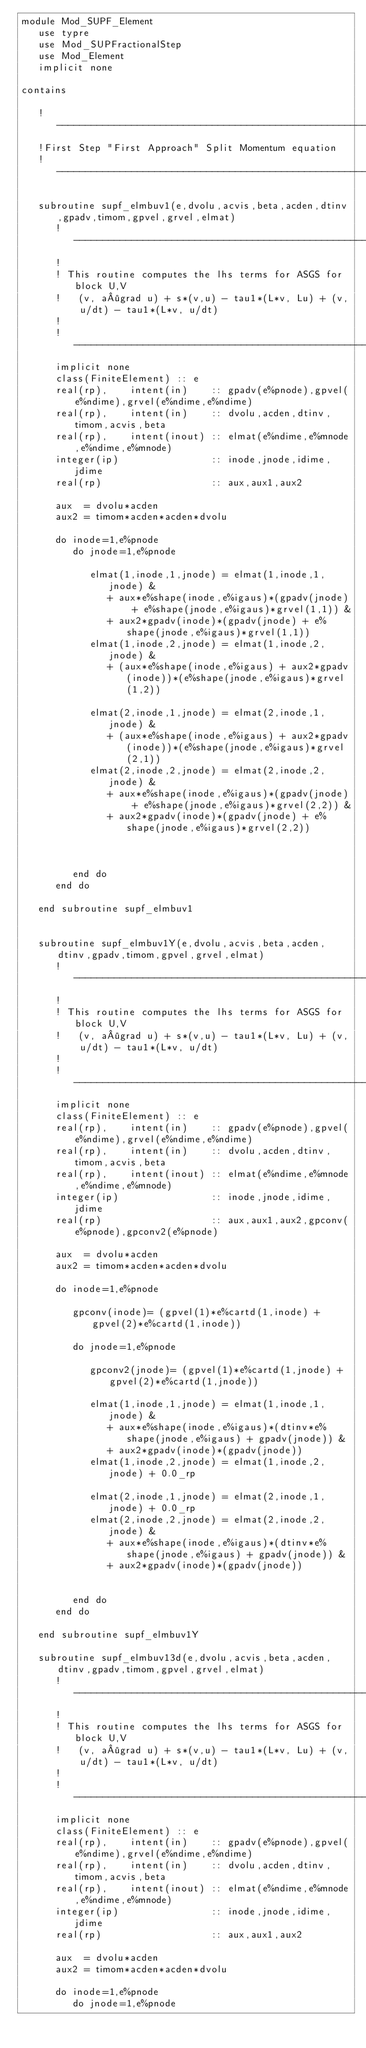<code> <loc_0><loc_0><loc_500><loc_500><_FORTRAN_>module Mod_SUPF_Element
   use typre
   use Mod_SUPFractionalStep
   use Mod_Element
   implicit none

contains
   
   !---------------------------------------------------------------------
   !First Step "First Approach" Split Momentum equation
   !---------------------------------------------------------------------
   
   subroutine supf_elmbuv1(e,dvolu,acvis,beta,acden,dtinv,gpadv,timom,gpvel,grvel,elmat)
      !-----------------------------------------------------------------------
      !
      ! This routine computes the lhs terms for ASGS for block U,V 
      !   (v, a·grad u) + s*(v,u) - tau1*(L*v, Lu) + (v, u/dt) - tau1*(L*v, u/dt)
      !
      !-----------------------------------------------------------------------
      implicit none
      class(FiniteElement) :: e
      real(rp),    intent(in)    :: gpadv(e%pnode),gpvel(e%ndime),grvel(e%ndime,e%ndime)
      real(rp),    intent(in)    :: dvolu,acden,dtinv,timom,acvis,beta
      real(rp),    intent(inout) :: elmat(e%ndime,e%mnode,e%ndime,e%mnode)
      integer(ip)                :: inode,jnode,idime,jdime
      real(rp)                   :: aux,aux1,aux2

      aux  = dvolu*acden
      aux2 = timom*acden*acden*dvolu
      
      do inode=1,e%pnode
         do jnode=1,e%pnode         

            elmat(1,inode,1,jnode) = elmat(1,inode,1,jnode) &
               + aux*e%shape(inode,e%igaus)*(gpadv(jnode) + e%shape(jnode,e%igaus)*grvel(1,1)) &
               + aux2*gpadv(inode)*(gpadv(jnode) + e%shape(jnode,e%igaus)*grvel(1,1))            
            elmat(1,inode,2,jnode) = elmat(1,inode,2,jnode) &
               + (aux*e%shape(inode,e%igaus) + aux2*gpadv(inode))*(e%shape(jnode,e%igaus)*grvel(1,2))
               
            elmat(2,inode,1,jnode) = elmat(2,inode,1,jnode) &
               + (aux*e%shape(inode,e%igaus) + aux2*gpadv(inode))*(e%shape(jnode,e%igaus)*grvel(2,1))               
            elmat(2,inode,2,jnode) = elmat(2,inode,2,jnode) &
               + aux*e%shape(inode,e%igaus)*(gpadv(jnode) + e%shape(jnode,e%igaus)*grvel(2,2)) &
               + aux2*gpadv(inode)*(gpadv(jnode) + e%shape(jnode,e%igaus)*grvel(2,2)) 
                 
               
               
         end do
      end do 

   end subroutine supf_elmbuv1 
   
   
   subroutine supf_elmbuv1Y(e,dvolu,acvis,beta,acden,dtinv,gpadv,timom,gpvel,grvel,elmat)
      !-----------------------------------------------------------------------
      !
      ! This routine computes the lhs terms for ASGS for block U,V 
      !   (v, a·grad u) + s*(v,u) - tau1*(L*v, Lu) + (v, u/dt) - tau1*(L*v, u/dt)
      !
      !-----------------------------------------------------------------------
      implicit none
      class(FiniteElement) :: e
      real(rp),    intent(in)    :: gpadv(e%pnode),gpvel(e%ndime),grvel(e%ndime,e%ndime)
      real(rp),    intent(in)    :: dvolu,acden,dtinv,timom,acvis,beta
      real(rp),    intent(inout) :: elmat(e%ndime,e%mnode,e%ndime,e%mnode)
      integer(ip)                :: inode,jnode,idime,jdime
      real(rp)                   :: aux,aux1,aux2,gpconv(e%pnode),gpconv2(e%pnode)

      aux  = dvolu*acden
      aux2 = timom*acden*acden*dvolu
      
      do inode=1,e%pnode
      
         gpconv(inode)= (gpvel(1)*e%cartd(1,inode) + gpvel(2)*e%cartd(1,inode))
         
         do jnode=1,e%pnode   
         
            gpconv2(jnode)= (gpvel(1)*e%cartd(1,jnode) + gpvel(2)*e%cartd(1,jnode))
         
            elmat(1,inode,1,jnode) = elmat(1,inode,1,jnode) &
               + aux*e%shape(inode,e%igaus)*(dtinv*e%shape(jnode,e%igaus) + gpadv(jnode)) &
               + aux2*gpadv(inode)*(gpadv(jnode))            
            elmat(1,inode,2,jnode) = elmat(1,inode,2,jnode) + 0.0_rp               
            
            elmat(2,inode,1,jnode) = elmat(2,inode,1,jnode) + 0.0_rp            
            elmat(2,inode,2,jnode) = elmat(2,inode,2,jnode) &
               + aux*e%shape(inode,e%igaus)*(dtinv*e%shape(jnode,e%igaus) + gpadv(jnode)) &
               + aux2*gpadv(inode)*(gpadv(jnode)) 

           
         end do
      end do 

   end subroutine supf_elmbuv1Y    
   
   subroutine supf_elmbuv13d(e,dvolu,acvis,beta,acden,dtinv,gpadv,timom,gpvel,grvel,elmat)
      !-----------------------------------------------------------------------
      !
      ! This routine computes the lhs terms for ASGS for block U,V 
      !   (v, a·grad u) + s*(v,u) - tau1*(L*v, Lu) + (v, u/dt) - tau1*(L*v, u/dt)
      !
      !-----------------------------------------------------------------------
      implicit none
      class(FiniteElement) :: e
      real(rp),    intent(in)    :: gpadv(e%pnode),gpvel(e%ndime),grvel(e%ndime,e%ndime)
      real(rp),    intent(in)    :: dvolu,acden,dtinv,timom,acvis,beta
      real(rp),    intent(inout) :: elmat(e%ndime,e%mnode,e%ndime,e%mnode)
      integer(ip)                :: inode,jnode,idime,jdime
      real(rp)                   :: aux,aux1,aux2
      
      aux  = dvolu*acden
      aux2 = timom*acden*acden*dvolu
      
      do inode=1,e%pnode
         do jnode=1,e%pnode</code> 